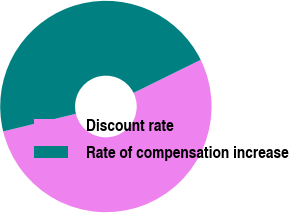Convert chart to OTSL. <chart><loc_0><loc_0><loc_500><loc_500><pie_chart><fcel>Discount rate<fcel>Rate of compensation increase<nl><fcel>53.49%<fcel>46.51%<nl></chart> 